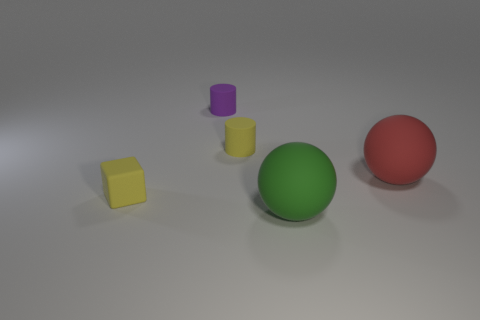What shape is the small yellow matte object that is in front of the object that is to the right of the big green ball that is in front of the large red matte thing?
Provide a succinct answer. Cube. There is a large green object that is the same shape as the red thing; what material is it?
Make the answer very short. Rubber. How many green rubber things are there?
Give a very brief answer. 1. There is a tiny yellow object to the right of the purple rubber object; what shape is it?
Make the answer very short. Cylinder. What color is the matte ball that is in front of the object that is right of the matte ball that is to the left of the big red object?
Give a very brief answer. Green. There is a red thing that is made of the same material as the small purple cylinder; what shape is it?
Ensure brevity in your answer.  Sphere. Are there fewer large spheres than blue objects?
Provide a succinct answer. No. Does the large green thing have the same material as the tiny purple thing?
Offer a very short reply. Yes. How many other objects are the same color as the cube?
Keep it short and to the point. 1. Are there more purple things than small gray balls?
Offer a terse response. Yes. 